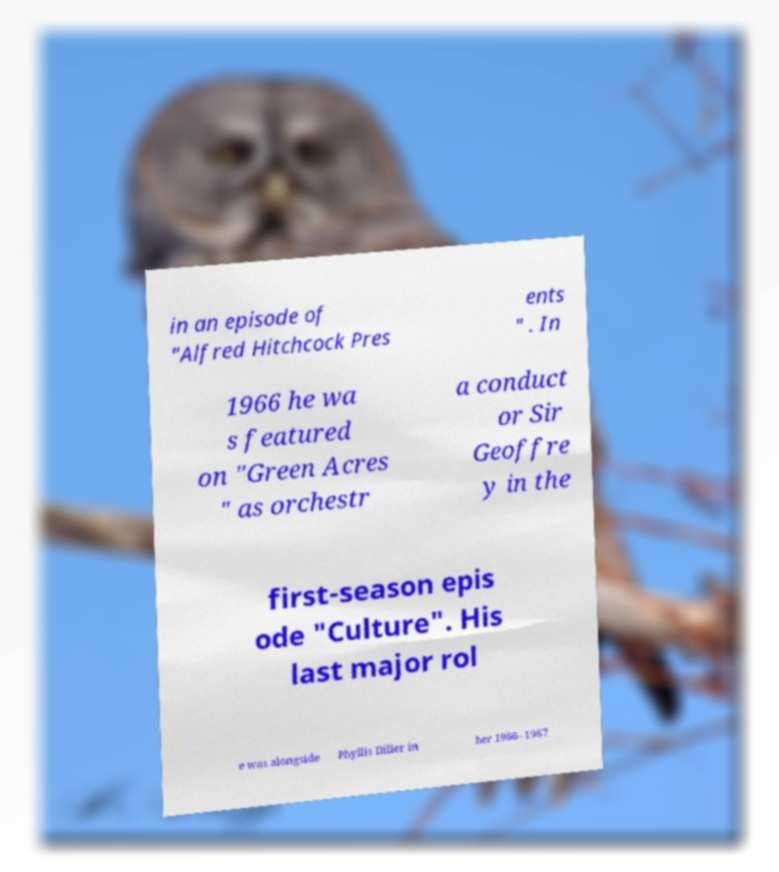There's text embedded in this image that I need extracted. Can you transcribe it verbatim? in an episode of "Alfred Hitchcock Pres ents " . In 1966 he wa s featured on "Green Acres " as orchestr a conduct or Sir Geoffre y in the first-season epis ode "Culture". His last major rol e was alongside Phyllis Diller in her 1966–1967 